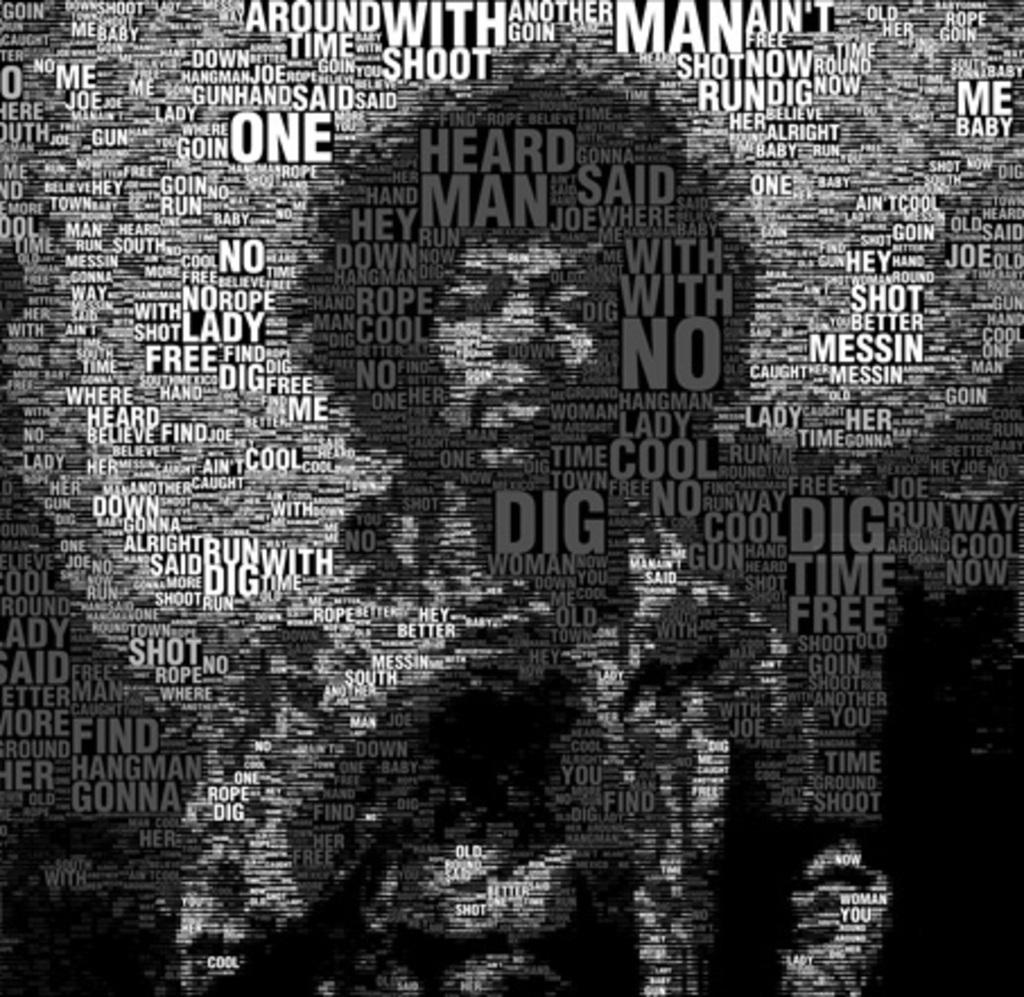<image>
Write a terse but informative summary of the picture. Poster of a black man with the words Lady Free Dig Me on it. 